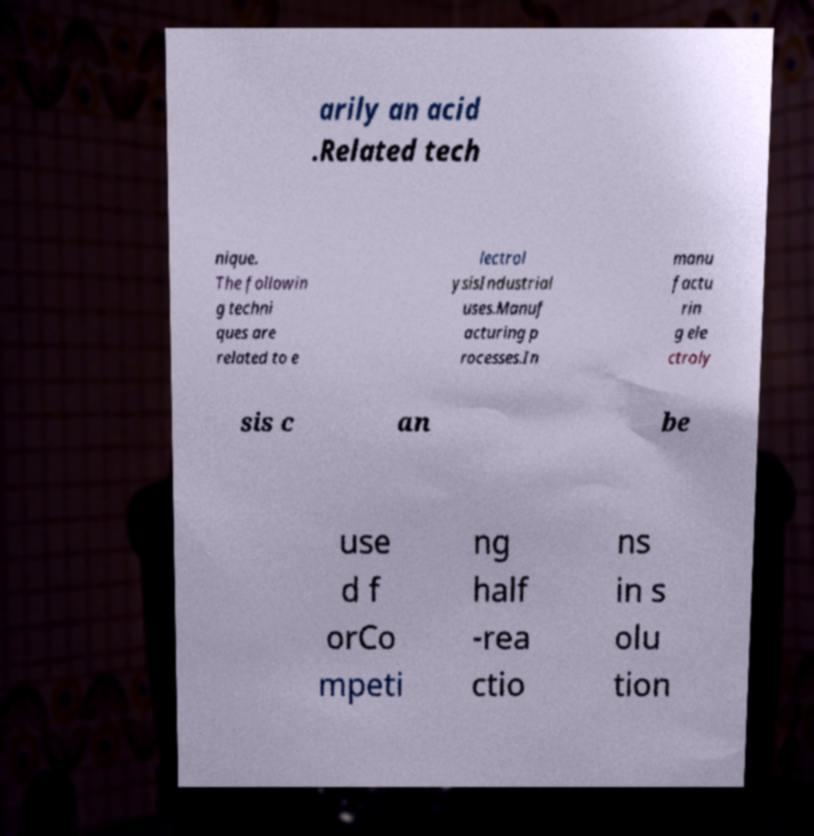There's text embedded in this image that I need extracted. Can you transcribe it verbatim? arily an acid .Related tech nique. The followin g techni ques are related to e lectrol ysisIndustrial uses.Manuf acturing p rocesses.In manu factu rin g ele ctroly sis c an be use d f orCo mpeti ng half -rea ctio ns in s olu tion 